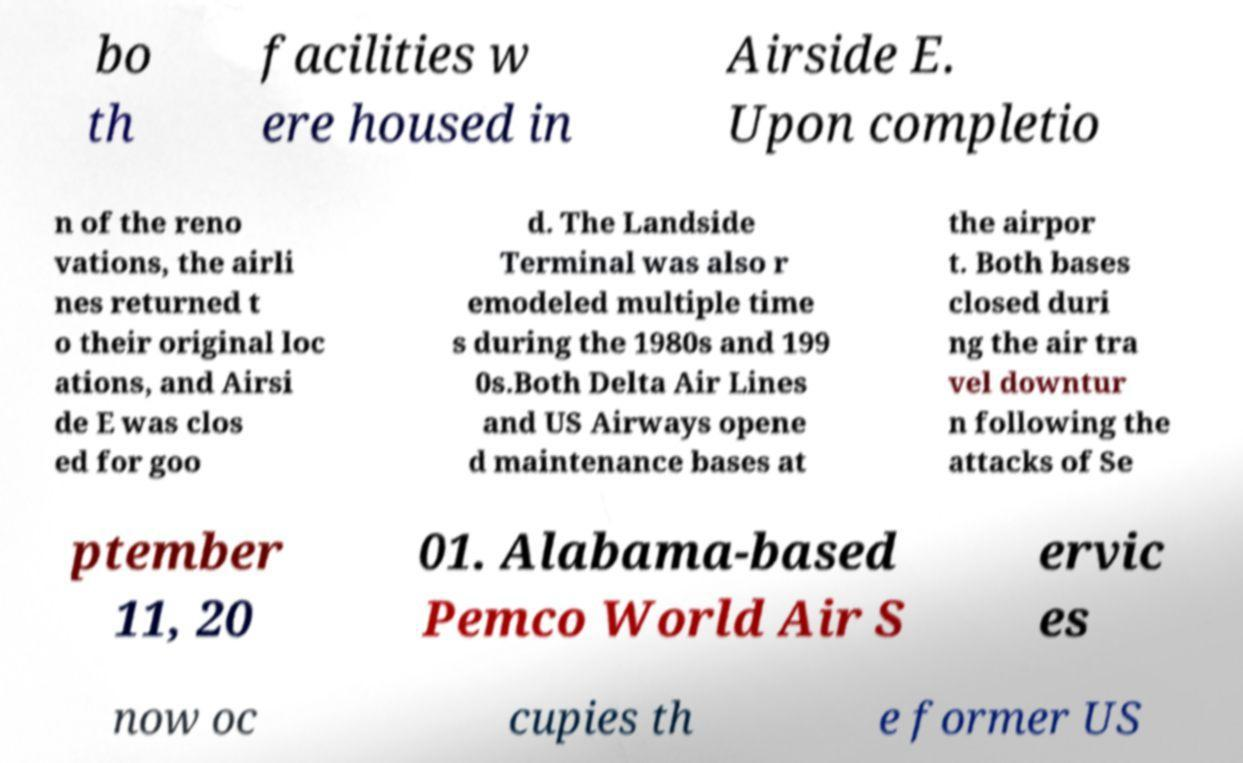Please read and relay the text visible in this image. What does it say? bo th facilities w ere housed in Airside E. Upon completio n of the reno vations, the airli nes returned t o their original loc ations, and Airsi de E was clos ed for goo d. The Landside Terminal was also r emodeled multiple time s during the 1980s and 199 0s.Both Delta Air Lines and US Airways opene d maintenance bases at the airpor t. Both bases closed duri ng the air tra vel downtur n following the attacks of Se ptember 11, 20 01. Alabama-based Pemco World Air S ervic es now oc cupies th e former US 